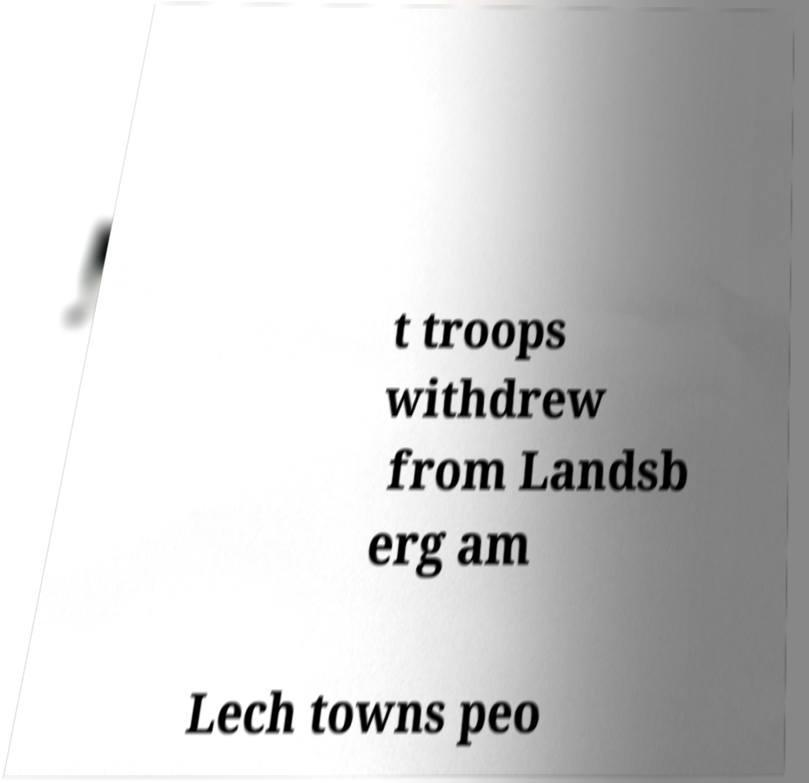I need the written content from this picture converted into text. Can you do that? t troops withdrew from Landsb erg am Lech towns peo 